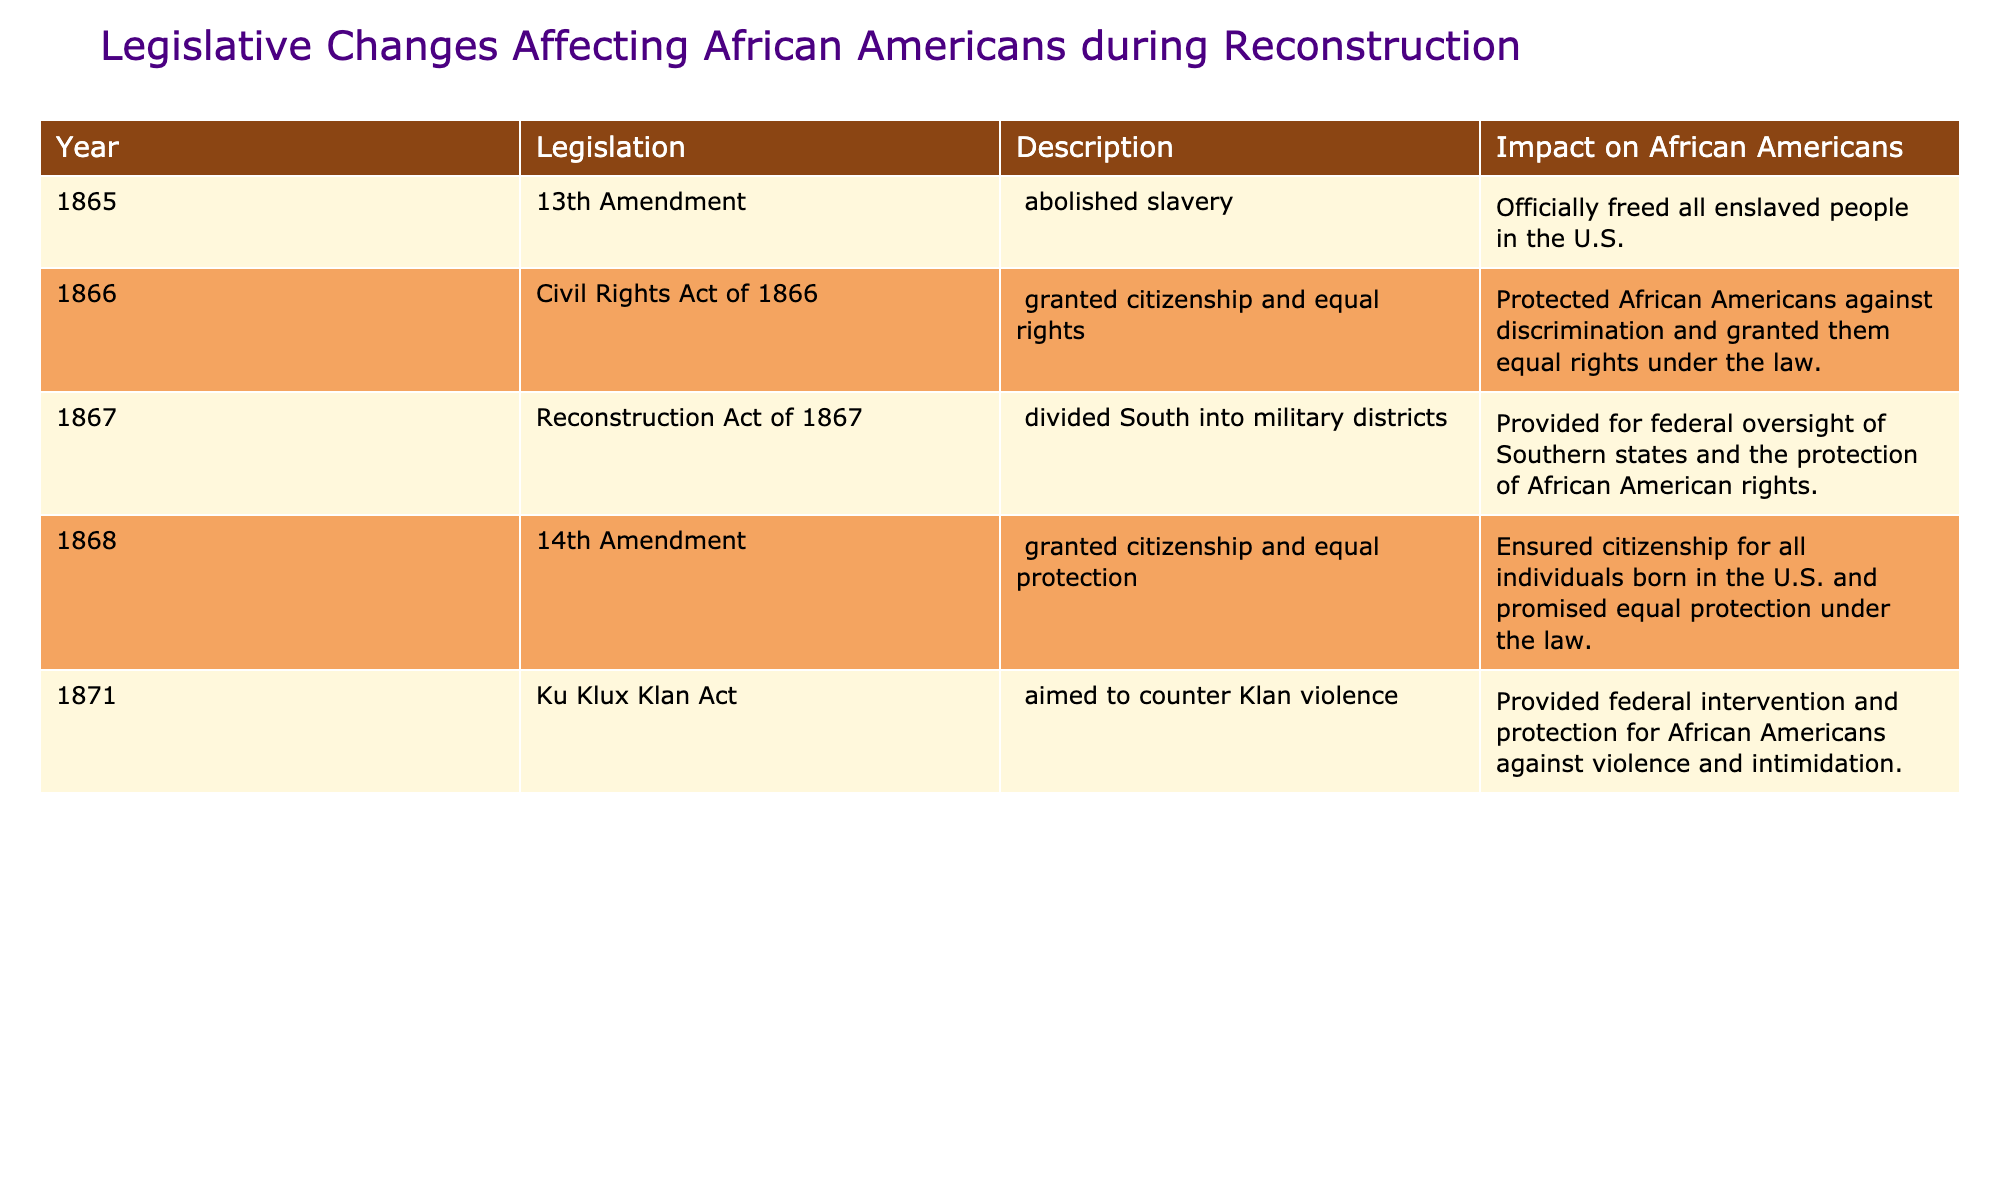What year was the 13th Amendment passed? The table states that the 13th Amendment, which abolished slavery, was passed in 1865.
Answer: 1865 What was the primary impact of the Civil Rights Act of 1866? According to the table, the Civil Rights Act of 1866 protected African Americans against discrimination and granted them equal rights under the law.
Answer: Protected African Americans against discrimination How many legislative changes are listed in the table? The table lists a total of five legislative changes affecting African Americans during and after Reconstruction.
Answer: 5 Which amendment granted citizenship and equal protection? The table indicates that the 14th Amendment, passed in 1868, granted citizenship and equal protection under the law.
Answer: 14th Amendment Did the Ku Klux Klan Act provide protection for African Americans? Yes, the table states that the Ku Klux Klan Act aimed to counter Klan violence and provided federal protection for African Americans against violence and intimidation.
Answer: Yes Which legislation aimed to provide federal oversight of Southern states? The Reconstruction Act of 1867, as listed in the table, provided for federal oversight of Southern states and the protection of African American rights.
Answer: Reconstruction Act of 1867 Which amendment abolished slavery and what was its impact? The 13th Amendment, which abolished slavery in 1865, officially freed all enslaved people in the U.S., as noted in the table.
Answer: Officially freed all enslaved people What is the year difference between the passing of the 13th and 14th Amendments? The 13th Amendment was passed in 1865 and the 14th Amendment in 1868, thus the difference is 3 years.
Answer: 3 years What legislation was enacted in 1871, and what was its purpose? The table states that the Ku Klux Klan Act was enacted in 1871, and its purpose was to counter Klan violence by providing federal intervention and protection for African Americans.
Answer: Ku Klux Klan Act Which year had two significant pieces of legislation affecting African Americans? The year 1866 had two significant pieces of legislation: the Civil Rights Act of 1866 and the Reconstruction Act.
Answer: 1866 